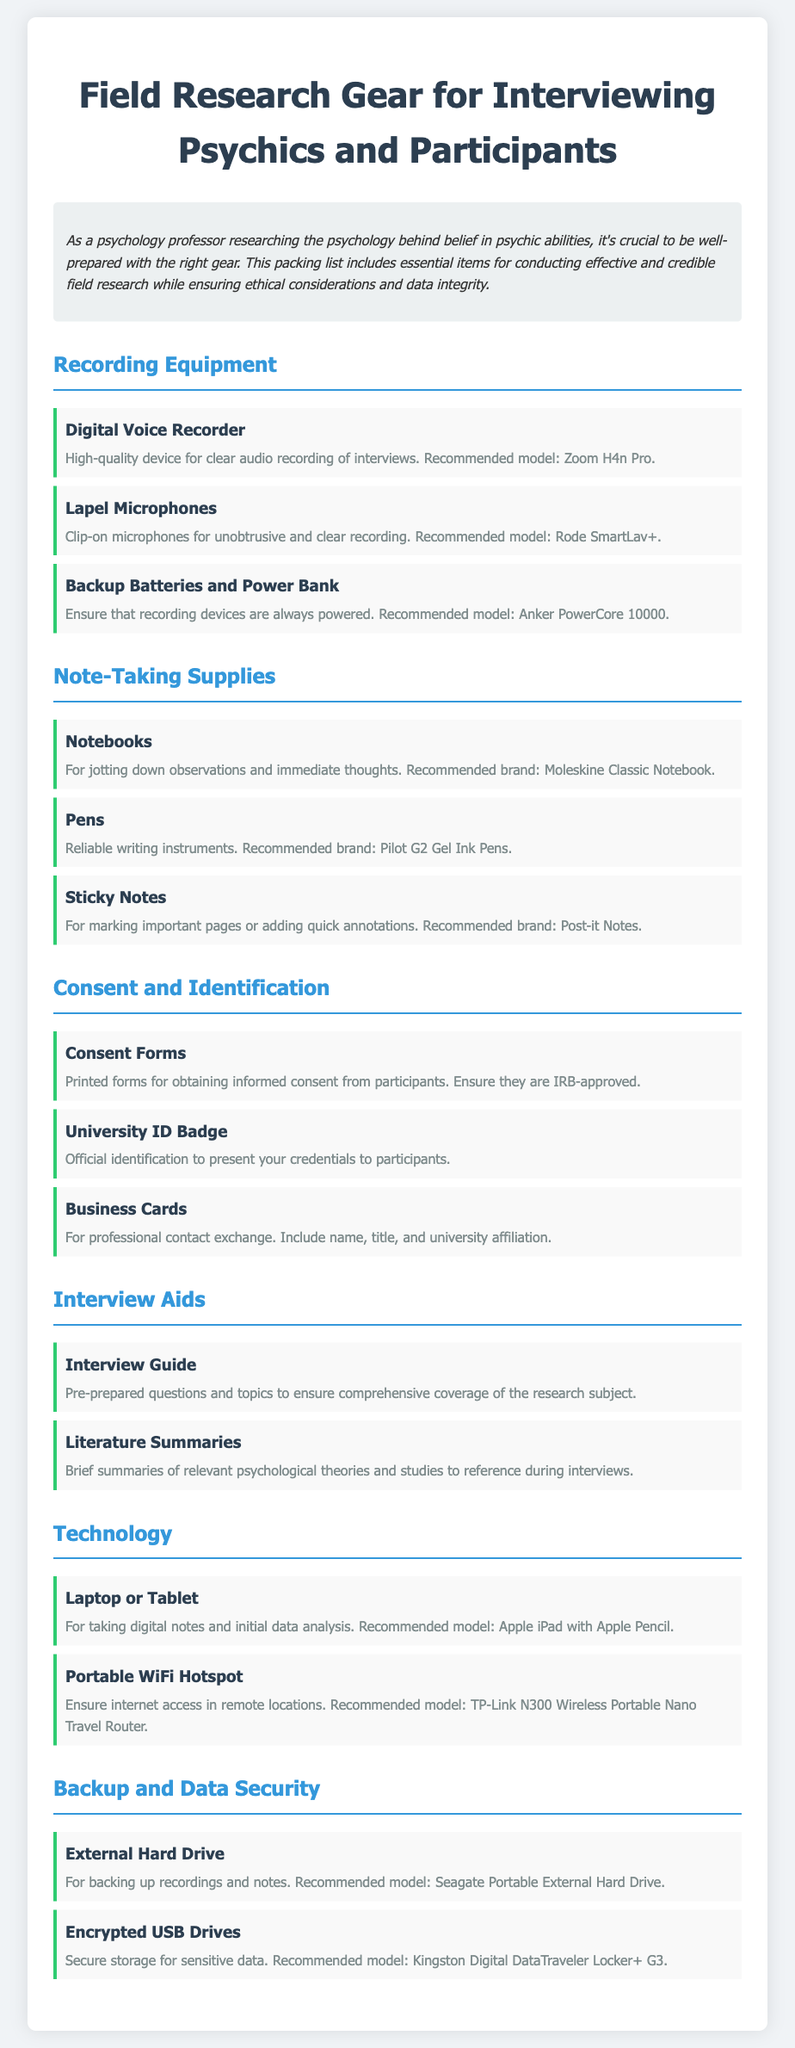What is the recommended model for the digital voice recorder? The document specifies the recommended model for the digital voice recorder as Zoom H4n Pro.
Answer: Zoom H4n Pro How many types of consent-related items are listed? The document lists three consent-related items: Consent Forms, University ID Badge, and Business Cards.
Answer: 3 What is the purpose of the Interview Guide? The Interview Guide is described as pre-prepared questions and topics to ensure comprehensive coverage of the research subject.
Answer: Comprehensive coverage What brand of pens is recommended? The document suggests using Pilot G2 Gel Ink Pens as a reliable writing instrument.
Answer: Pilot G2 Gel Ink Pens What is the function of the external hard drive? The external hard drive is mentioned for backing up recordings and notes during field research.
Answer: Backing up recordings and notes What technology item is recommended for note-taking? The document recommends using an Apple iPad with Apple Pencil for taking digital notes.
Answer: Apple iPad with Apple Pencil How many sections are in the packing list? The packing list comprises six sections: Recording Equipment, Note-Taking Supplies, Consent and Identification, Interview Aids, Technology, and Backup and Data Security.
Answer: 6 What is the recommended model for the portable WiFi hotspot? The document states the recommended model for the portable WiFi hotspot as TP-Link N300 Wireless Portable Nano Travel Router.
Answer: TP-Link N300 Wireless Portable Nano Travel Router What is the purpose of the consent forms? The consent forms are used for obtaining informed consent from participants as per ethical guidelines.
Answer: Obtain informed consent 